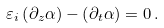Convert formula to latex. <formula><loc_0><loc_0><loc_500><loc_500>\varepsilon _ { i } \left ( \partial _ { z } \alpha \right ) - \left ( \partial _ { t } \alpha \right ) = 0 \, .</formula> 